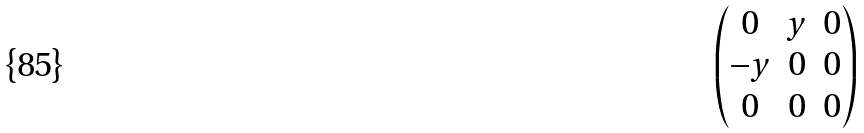Convert formula to latex. <formula><loc_0><loc_0><loc_500><loc_500>\begin{pmatrix} 0 & y & 0 \\ - y & 0 & 0 \\ 0 & 0 & 0 \end{pmatrix}</formula> 